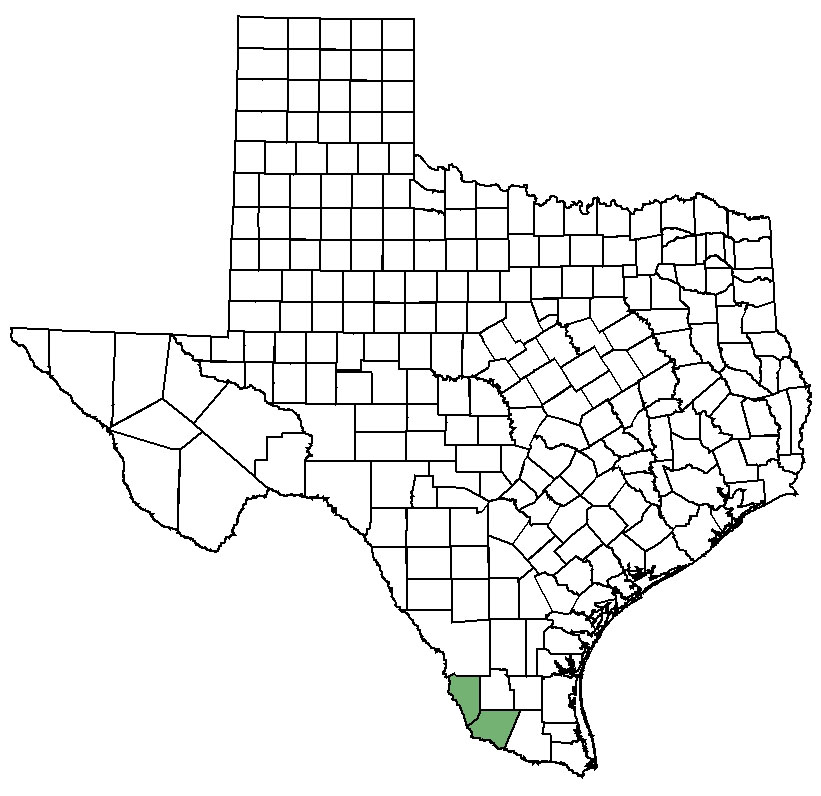Considering the highlighted county, what might be the reason for its distinct coloring? Without additional context, the exact reason for the distinct coloring of the highlighted county is speculative. Typically, unique coloring on a map can indicate several things. It might highlight political boundaries, demographic distinctions, or geographic features. It could also signify the focus of specific information, such as containing a national park, historical significance, or being the subject of particular statistical representation like population density, economic status, or impact of certain policies or events. For precise interpretation, accompanying legends or textual information would be necessary. 